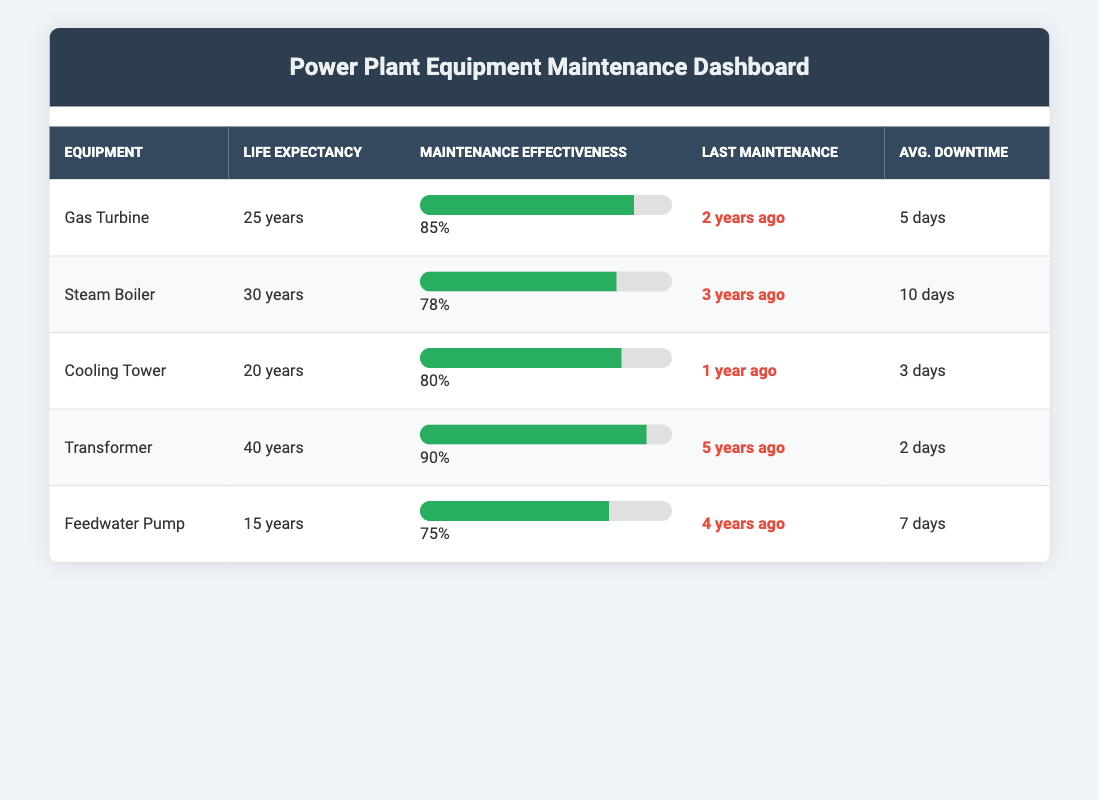What is the average life expectancy of all the equipment listed? To find the average, sum the life expectancies: 25 + 30 + 20 + 40 + 15 = 140. There are 5 pieces of equipment, so the average is 140 / 5 = 28 years.
Answer: 28 years Which equipment has the highest predictive maintenance effectiveness? The data shows that the Transformer has a predictive maintenance effectiveness of 90%, which is the highest among all equipment listed.
Answer: Transformer Is the average downtime of the Gas Turbine less than that of the Steam Boiler? The average downtime for the Gas Turbine is 5 days while for the Steam Boiler it is 10 days. Since 5 is less than 10, the statement is true.
Answer: Yes What is the difference in average downtime between the Cooling Tower and the Feedwater Pump? The average downtime for the Cooling Tower is 3 days and for the Feedwater Pump is 7 days. The difference is 7 - 3 = 4 days.
Answer: 4 days How many years ago did the Transformer last undergo maintenance? According to the table, the Transformer underwent maintenance 5 years ago.
Answer: 5 years ago Which equipment has the lowest predictive maintenance effectiveness, and what is its value? The Feedwater Pump has the lowest predictive maintenance effectiveness at 75%.
Answer: Feedwater Pump, 75% If we consider only the equipment with an average life expectancy greater than 20 years, what is the average predictive maintenance effectiveness for those pieces? The relevant equipment with more than 20 years of life expectancy are the Transformer (90%), Steam Boiler (78%), and Gas Turbine (85%). Their average effectiveness is (90 + 78 + 85) / 3 = 251 / 3 = 83.67%.
Answer: 83.67% Does the Cooling Tower have a higher average life expectancy than the Feedwater Pump? The Cooling Tower has an average life expectancy of 20 years, while the Feedwater Pump has 15 years. Since 20 is greater than 15, this is true.
Answer: Yes What is the overall maintenance effectiveness of all the equipment combined? The overall maintenance effectiveness is calculated by finding the average of individual effectiveness: (85 + 78 + 80 + 90 + 75) / 5 = 408 / 5 = 81.6%.
Answer: 81.6% 